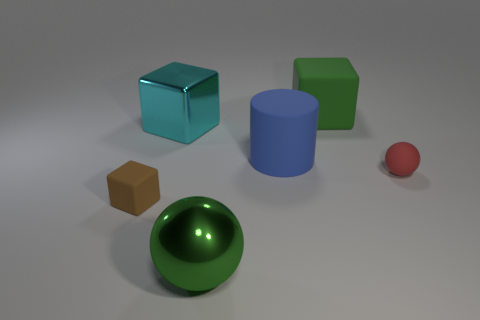Subtract all small brown blocks. How many blocks are left? 2 Subtract all green cubes. How many cubes are left? 2 Add 1 big blue rubber cylinders. How many objects exist? 7 Subtract all cylinders. How many objects are left? 5 Add 4 green spheres. How many green spheres are left? 5 Add 3 brown things. How many brown things exist? 4 Subtract 0 purple cubes. How many objects are left? 6 Subtract all red cubes. Subtract all brown spheres. How many cubes are left? 3 Subtract all big green shiny things. Subtract all tiny brown rubber things. How many objects are left? 4 